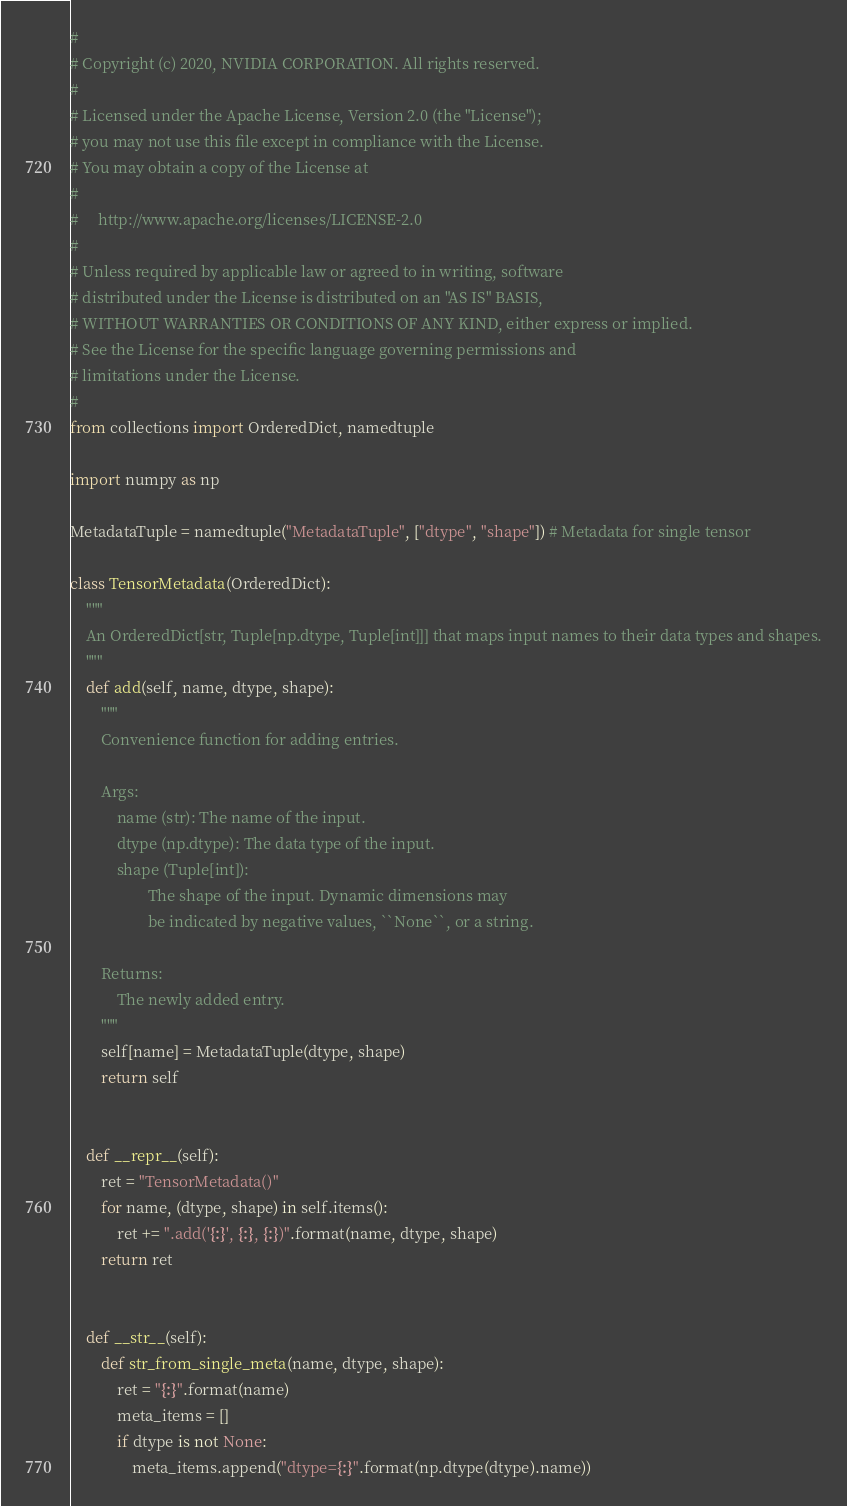<code> <loc_0><loc_0><loc_500><loc_500><_Python_>#
# Copyright (c) 2020, NVIDIA CORPORATION. All rights reserved.
#
# Licensed under the Apache License, Version 2.0 (the "License");
# you may not use this file except in compliance with the License.
# You may obtain a copy of the License at
#
#     http://www.apache.org/licenses/LICENSE-2.0
#
# Unless required by applicable law or agreed to in writing, software
# distributed under the License is distributed on an "AS IS" BASIS,
# WITHOUT WARRANTIES OR CONDITIONS OF ANY KIND, either express or implied.
# See the License for the specific language governing permissions and
# limitations under the License.
#
from collections import OrderedDict, namedtuple

import numpy as np

MetadataTuple = namedtuple("MetadataTuple", ["dtype", "shape"]) # Metadata for single tensor

class TensorMetadata(OrderedDict):
    """
    An OrderedDict[str, Tuple[np.dtype, Tuple[int]]] that maps input names to their data types and shapes.
    """
    def add(self, name, dtype, shape):
        """
        Convenience function for adding entries.

        Args:
            name (str): The name of the input.
            dtype (np.dtype): The data type of the input.
            shape (Tuple[int]):
                    The shape of the input. Dynamic dimensions may
                    be indicated by negative values, ``None``, or a string.

        Returns:
            The newly added entry.
        """
        self[name] = MetadataTuple(dtype, shape)
        return self


    def __repr__(self):
        ret = "TensorMetadata()"
        for name, (dtype, shape) in self.items():
            ret += ".add('{:}', {:}, {:})".format(name, dtype, shape)
        return ret


    def __str__(self):
        def str_from_single_meta(name, dtype, shape):
            ret = "{:}".format(name)
            meta_items = []
            if dtype is not None:
                meta_items.append("dtype={:}".format(np.dtype(dtype).name))</code> 